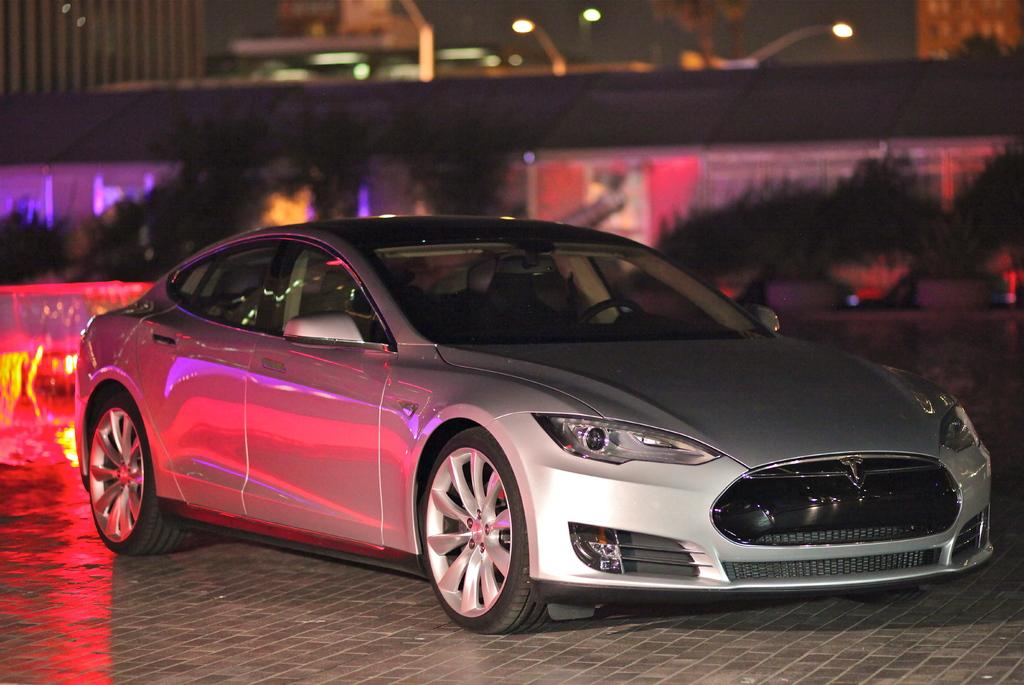What is the main subject in the center of the image? There is a car in the center of the image. What can be seen in the background of the image? There are buildings, trees, lights, and some objects in the background of the image. What is at the bottom of the image? There is a walkway at the bottom of the image. What type of pie is being served on the car's hood in the image? There is no pie present in the image; it features a car, buildings, trees, lights, and a walkway. Can you see a bat flying around the car in the image? There is no bat present in the image; it only features a car, buildings, trees, lights, and a walkway. 